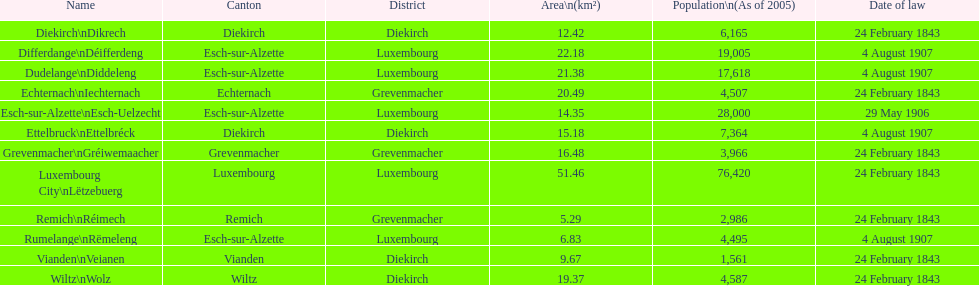Which canton is subject to the legislation of february 24, 1843, and has a population count of 3,966? Grevenmacher. 